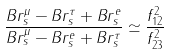<formula> <loc_0><loc_0><loc_500><loc_500>\frac { B r ^ { \mu } _ { s } - B r ^ { \tau } _ { s } + B r ^ { e } _ { s } } { B r ^ { \mu } _ { s } - B r ^ { e } _ { s } + B r ^ { \tau } _ { s } } \simeq \frac { f _ { 1 2 } ^ { 2 } } { f _ { 2 3 } ^ { 2 } }</formula> 